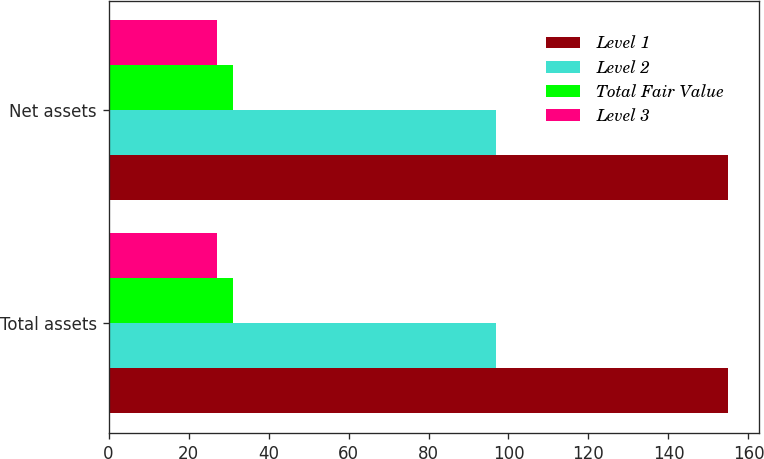Convert chart to OTSL. <chart><loc_0><loc_0><loc_500><loc_500><stacked_bar_chart><ecel><fcel>Total assets<fcel>Net assets<nl><fcel>Level 1<fcel>155<fcel>155<nl><fcel>Level 2<fcel>97<fcel>97<nl><fcel>Total Fair Value<fcel>31<fcel>31<nl><fcel>Level 3<fcel>27<fcel>27<nl></chart> 